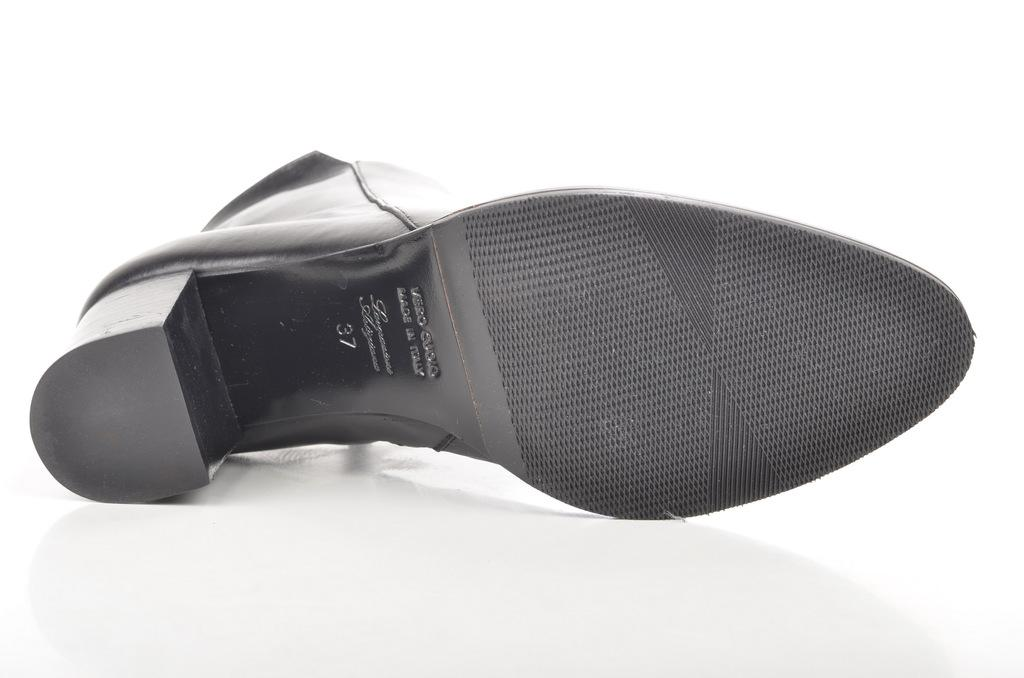What object can be seen in the image? There is a shoe in the image. What is unique about the shoe? There is writing on the shoe. What color is the writing on the shoe? The writing is in black color. Can you describe the wilderness surrounding the shoe in the image? There is no wilderness present in the image; it only features a shoe with writing on it. 